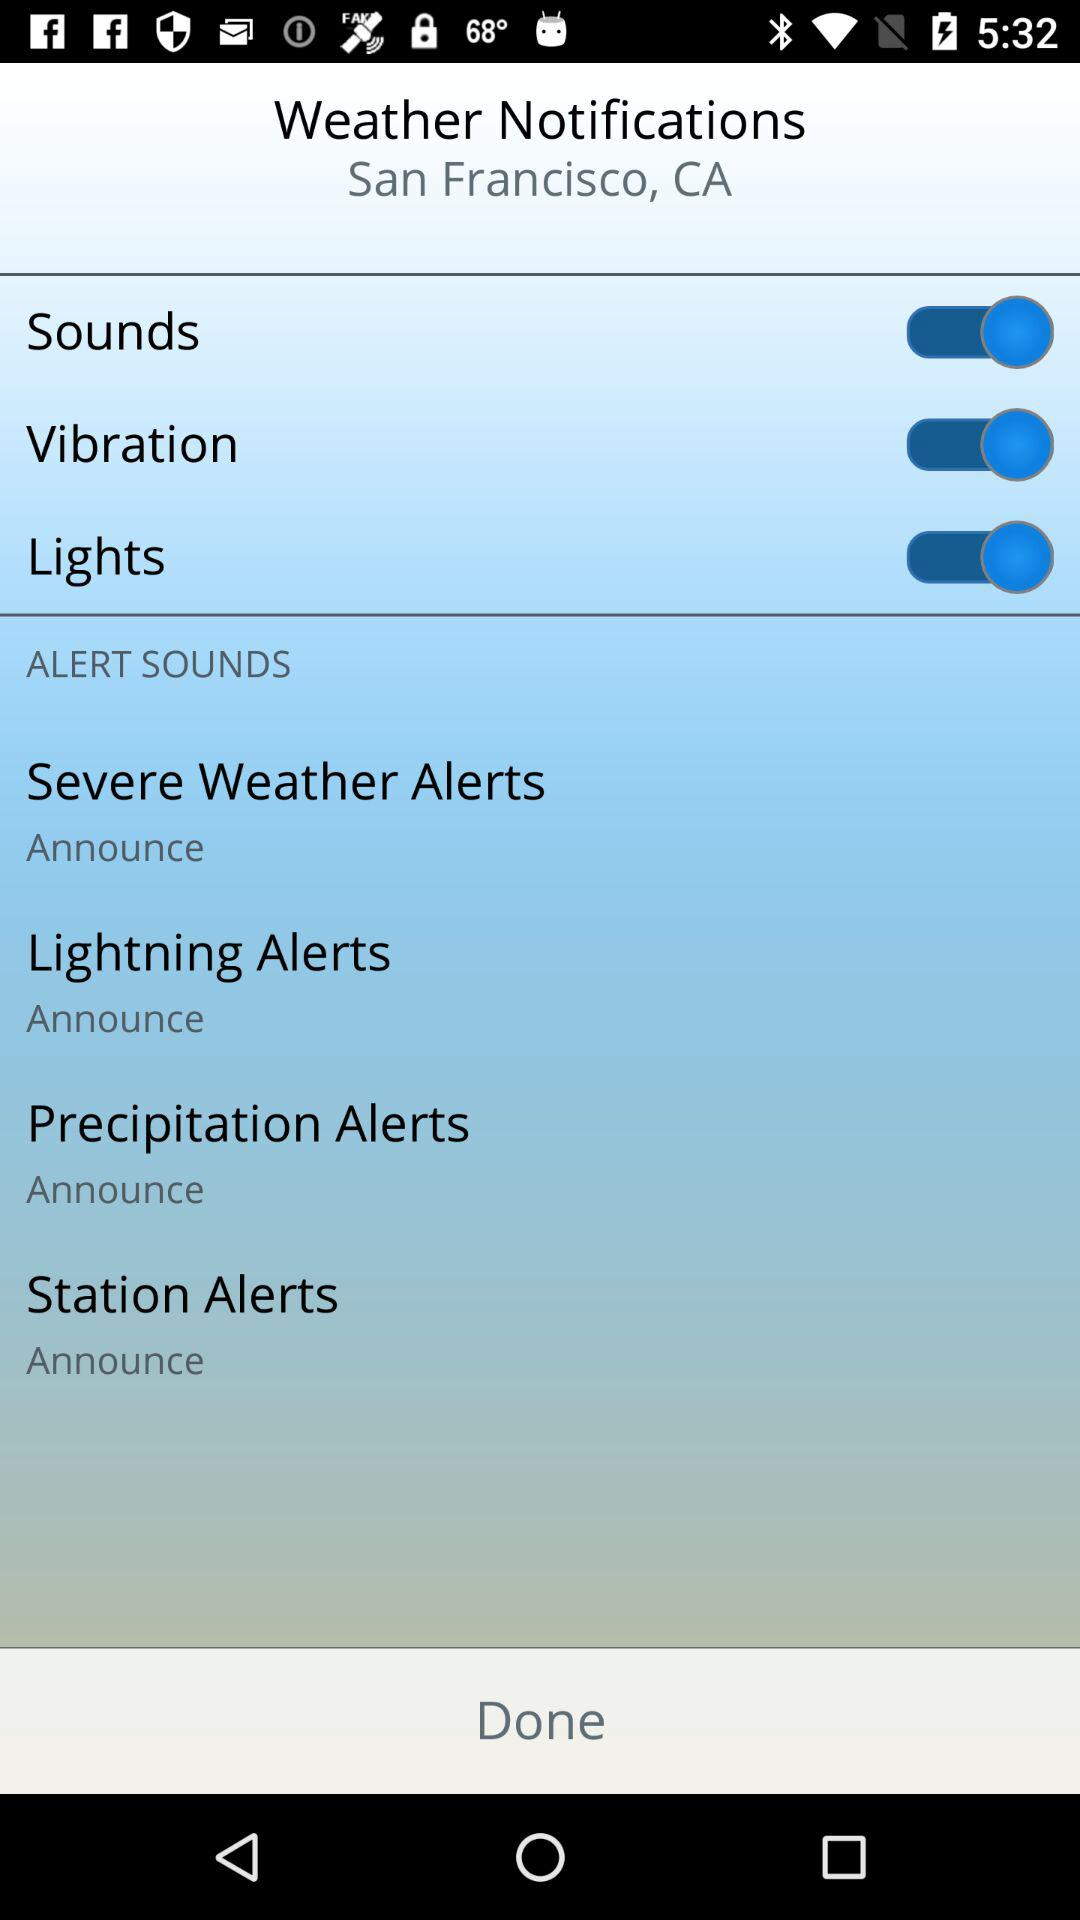How many alert types are there?
Answer the question using a single word or phrase. 4 